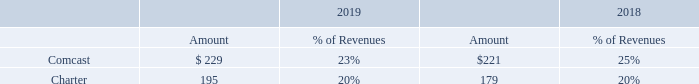Description of Business
Key Clients. We work with the leading communication service providers located around the world. A partial list of our key clients as of December 31, 2019 is included below:
Clients that represented 10% or more of our revenues for 2019 and 2018 were as follows (in millions, except percentages):
See the Significant Client Relationships section of our Management’s Discussion and Analysis (“MD&A”) for additional information regarding our business relationships with these key clients.
Research and Development. Our clients around the world are facing competition from new entrants and at the same time, are deploying new services at a rapid pace and dramatically increasing the complexity of their business operations. Therefore, we continue to make meaningful investments in R&D to ensure that we stay ahead of our clients’ needs and advance our clients’ businesses as well as our own. We believe our value proposition is to provide solutions that help our clients ensure that each customer interaction is an opportunity to create value and deepen the business relationship.
Our total R&D expenses for 2019 and 2018 were $128.0 million and $124.0 million, respectively, or approximately 13% and 14%, respectively, of our total revenues. We anticipate the level of R&D investment in the near-term to be relatively consistent with that of 2019.
There are certain inherent risks associated with significant technological innovations. Some of these risks are described in this report in our Risk Factors section below.
What are the customers that represent 10% or more of the company's revenue in 2019? Comcast, charter. What is the total revenue earned from Comcast in 2018 and 2019?
Answer scale should be: million. $(229 + 221) 
Answer: 450. What is the average revenue earned by Comcast between 2018 and 2019?
Answer scale should be: million. $(229 + 221)/2 
Answer: 225. What is the company's R&D expenses in 2018? $128.0 million. Who does the company work with? Leading communication service providers located around the world. How many companies individually account for 10% or more of the revenue of the company in 2019?  Comcast##Charter
Answer: 2. 